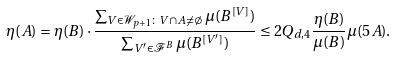Convert formula to latex. <formula><loc_0><loc_0><loc_500><loc_500>\eta ( A ) & = \eta ( B ) \cdot \frac { \sum _ { V \in \mathcal { W } _ { p + 1 } \colon V \cap A \neq \emptyset } \mu ( B ^ { [ V ] } ) } { \sum _ { V ^ { \prime } \in \mathcal { F } ^ { B } } \mu ( B ^ { [ V ^ { \prime } ] } ) } \leq 2 Q _ { d , 4 } \frac { \eta ( B ) } { \mu ( B ) } \mu ( 5 A ) .</formula> 